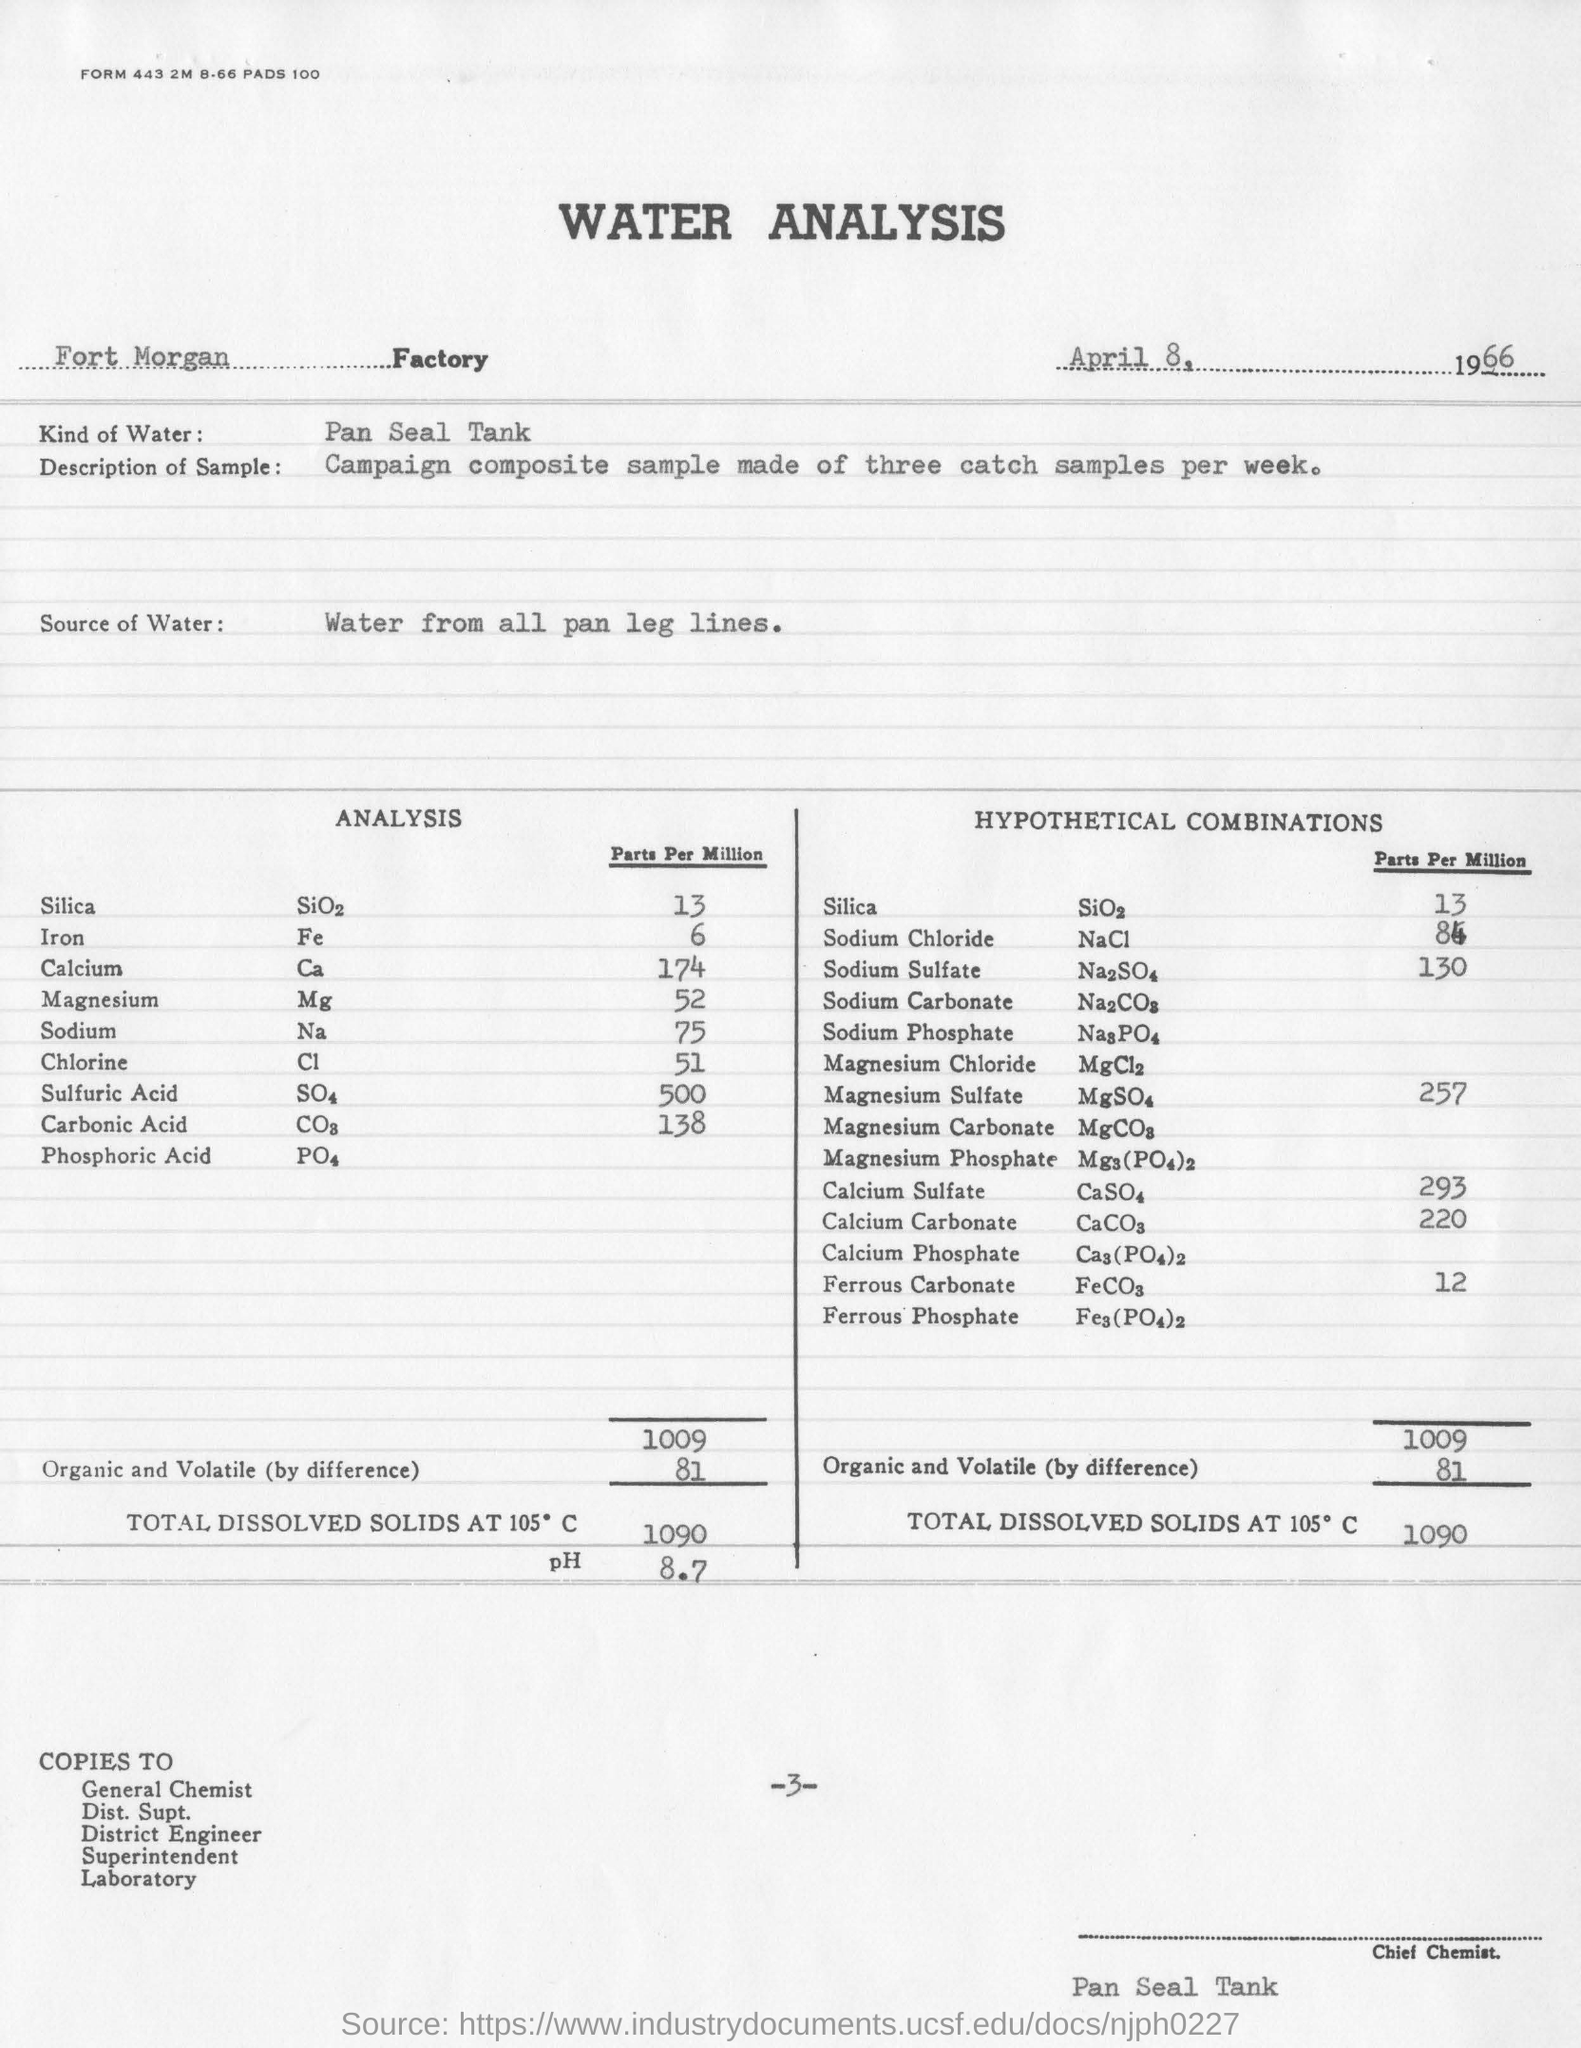What is the date on the analysis?
Your answer should be compact. April 8, 1966. How many samples were taken?
Ensure brevity in your answer.  Three. How many parts per million of silica was there in the hypothetical combinations?
Ensure brevity in your answer.  13. 